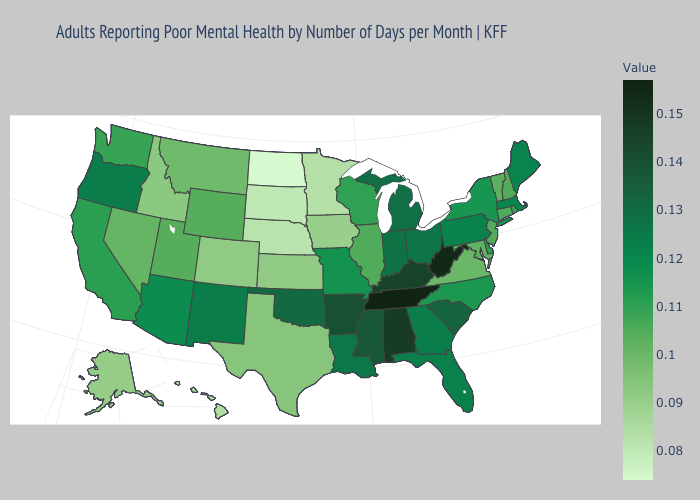Among the states that border South Carolina , which have the lowest value?
Concise answer only. North Carolina. Does Maine have the lowest value in the Northeast?
Short answer required. No. Does the map have missing data?
Short answer required. No. Is the legend a continuous bar?
Give a very brief answer. Yes. Which states have the highest value in the USA?
Quick response, please. Tennessee. Which states have the lowest value in the USA?
Answer briefly. North Dakota. 